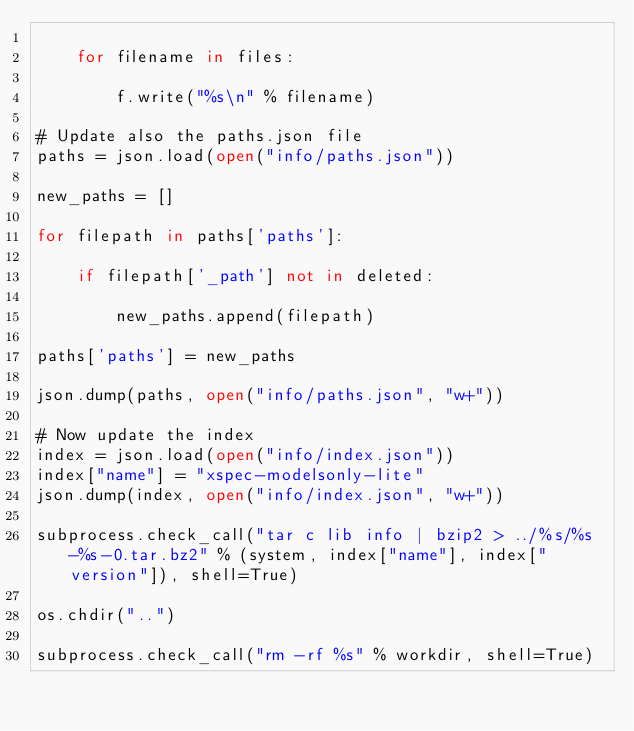<code> <loc_0><loc_0><loc_500><loc_500><_Python_>    
    for filename in files:
        
        f.write("%s\n" % filename)

# Update also the paths.json file
paths = json.load(open("info/paths.json"))

new_paths = []

for filepath in paths['paths']:
    
    if filepath['_path'] not in deleted:
        
        new_paths.append(filepath)

paths['paths'] = new_paths

json.dump(paths, open("info/paths.json", "w+"))

# Now update the index
index = json.load(open("info/index.json"))
index["name"] = "xspec-modelsonly-lite"
json.dump(index, open("info/index.json", "w+"))

subprocess.check_call("tar c lib info | bzip2 > ../%s/%s-%s-0.tar.bz2" % (system, index["name"], index["version"]), shell=True)

os.chdir("..")

subprocess.check_call("rm -rf %s" % workdir, shell=True)
</code> 